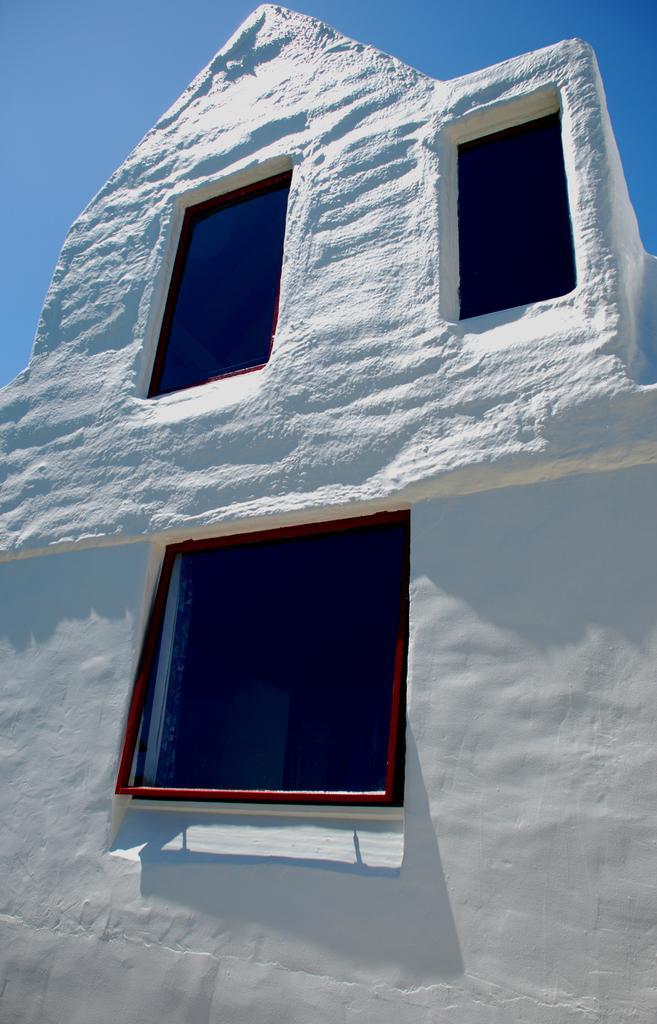In one or two sentences, can you explain what this image depicts? In the foreground of this image, there is a building and three windows to it. On the top, there is the sky. 